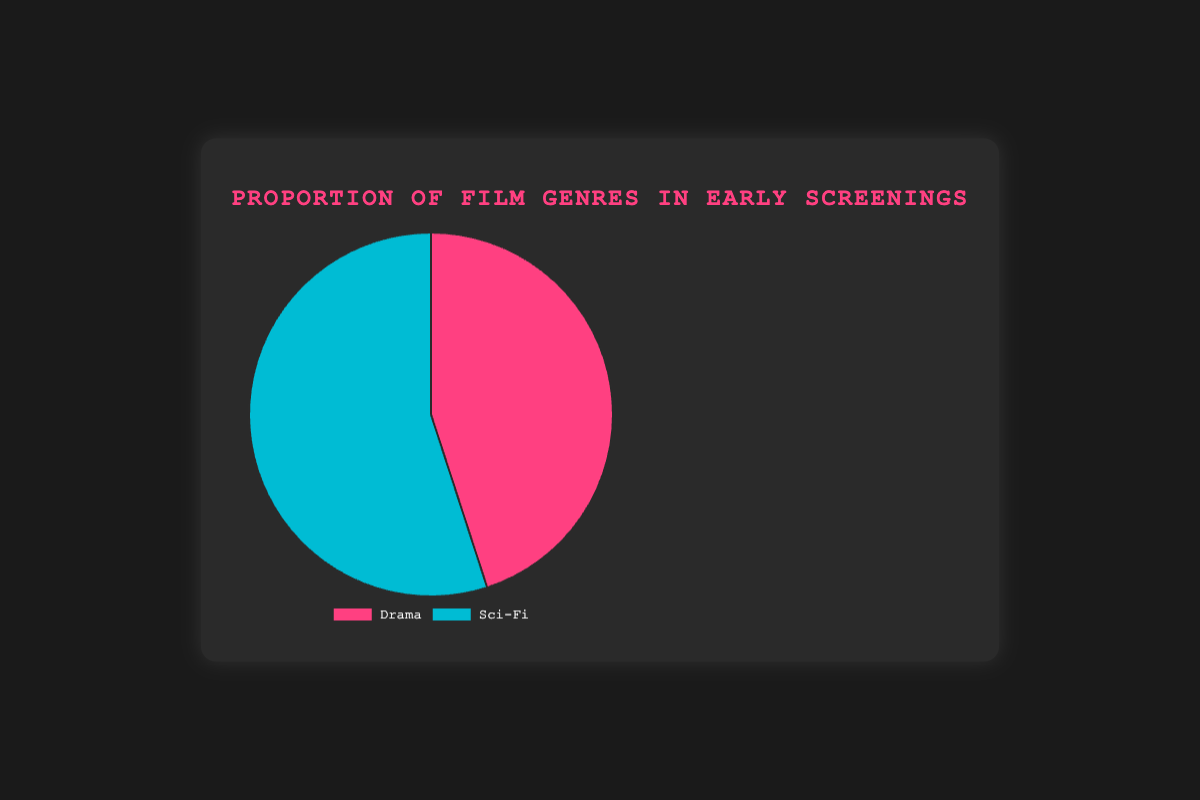What proportion of early screenings is for Drama films? The pie chart shows the Drama proportion in early screenings is 45%.
Answer: 45% Which genre has a higher proportion in early screenings, Drama or Sci-Fi? By comparing the pie chart sections, Sci-Fi has a higher proportion at 55% compared to Drama at 45%.
Answer: Sci-Fi What is the difference in proportion between Drama and Sci-Fi films in early screenings? Subtract the Drama proportion (45%) from the Sci-Fi proportion (55%). 55% - 45% = 10%.
Answer: 10% What percentage of early screenings is not Sci-Fi? If Sci-Fi is 55%, then the remainder is for Drama. 100% - 55% = 45%.
Answer: 45% How do the visual sizes of the pie chart sections for Drama and Sci-Fi compare? The Sci-Fi section takes up more space visually, indicating its higher proportion of 55% compared to Drama's 45%.
Answer: Sci-Fi section is larger If we combined Sci-Fi and Drama films, what percentage would they collectively account for in early screenings? Adding the proportions of Drama and Sci-Fi: 45% + 55% = 100%.
Answer: 100% Which section of the pie chart is colored blue? By referring to the legend, the Sci-Fi genre, which has a proportion of 55%, is colored blue.
Answer: Sci-Fi 